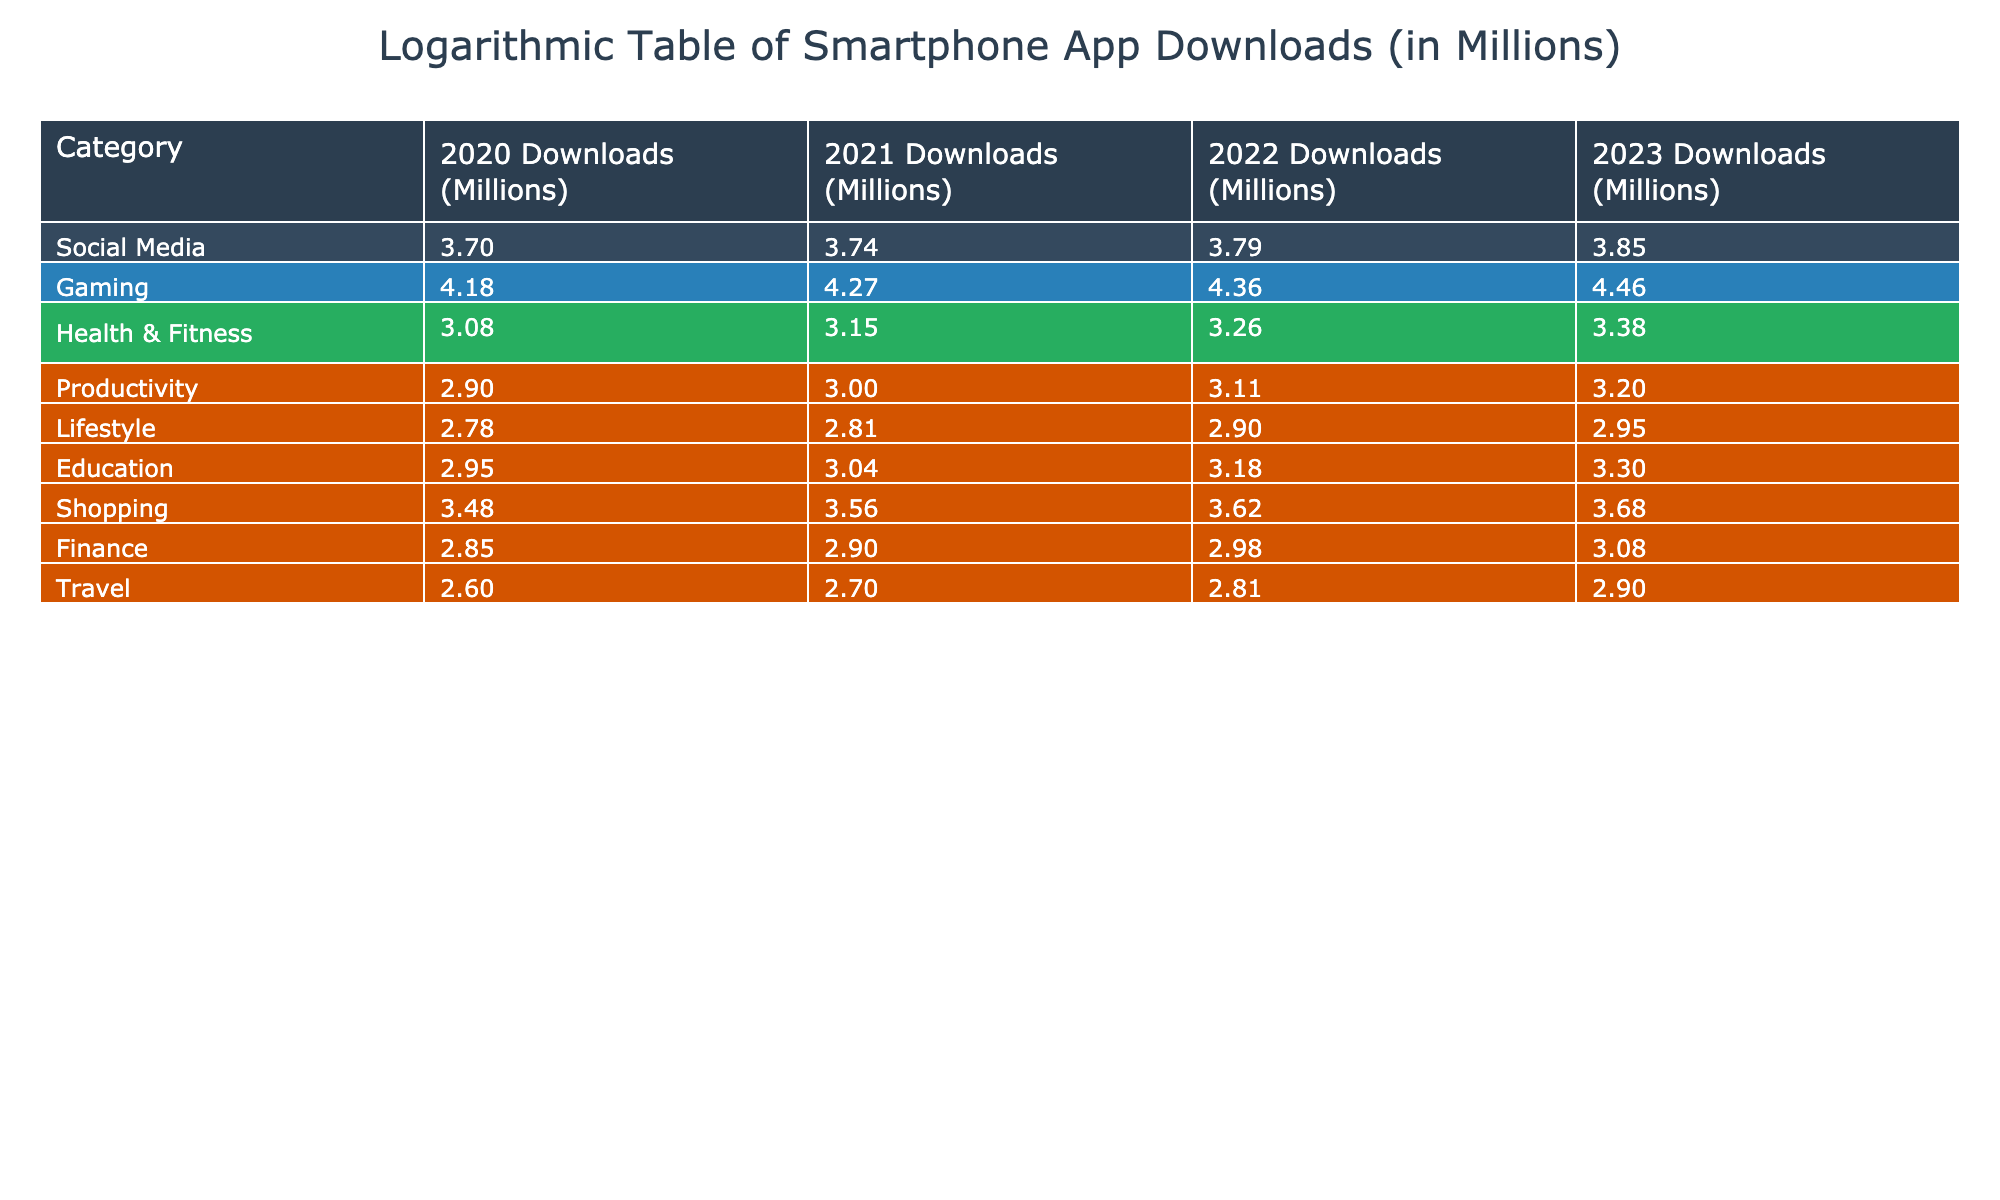What was the download figure for the Gaming category in 2022? Referring to the table, the download figure for the Gaming category in 2022 is specifically listed under that category, which shows 23000 million downloads.
Answer: 23000 Which category experienced the highest growth in downloads from 2020 to 2023? To determine this, compare the downloads for each category across the years 2020 and 2023. The Gaming category increased from 15000 to 29000, resulting in a growth of 14000 million. This is higher than other categories.
Answer: Gaming What is the percentage growth of downloads in the Health & Fitness category from 2020 to 2023? The percentage growth can be calculated as [(2400 - 1200) / 1200] x 100. The difference is 1200, and dividing 1200 by 1200 gives 1, converting to a percentage results in 100%.
Answer: 100% Is the download figure for Shopping higher than that for Lifestyle in 2021? In 2021, Shopping had 3600 million, while Lifestyle had 650 million. Comparing these values shows that 3600 million is greater than 650 million.
Answer: Yes What is the average download figure across all categories for the year 2023? Add the downloads for each category in 2023: 7000 (Social Media) + 29000 (Gaming) + 2400 (Health & Fitness) + 1600 (Productivity) + 900 (Lifestyle) + 2000 (Education) + 4800 (Shopping) + 1200 (Finance) + 800 (Travel) = 43700 million. Then, divide by the number of categories (9): 43700 / 9 ≈ 4866.67 million.
Answer: 4866.67 How many categories had downloads below 3000 millions in 2022? Check the download figures for 2022. The categories with below 3000 million are Health & Fitness (1800), Productivity (1300), Lifestyle (800), Education (1500), Finance (950), and Travel (650), totaling six categories.
Answer: 6 